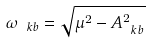Convert formula to latex. <formula><loc_0><loc_0><loc_500><loc_500>\omega _ { \ k b } = \sqrt { \mu ^ { 2 } - A _ { \ k b } ^ { 2 } }</formula> 